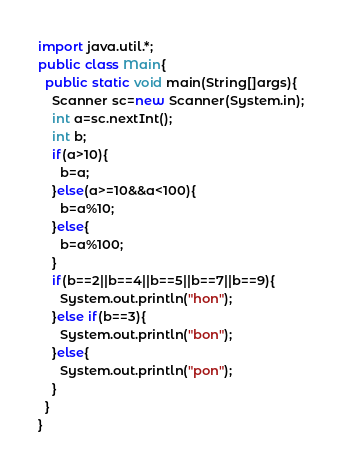Convert code to text. <code><loc_0><loc_0><loc_500><loc_500><_Java_>import java.util.*;
public class Main{
  public static void main(String[]args){
    Scanner sc=new Scanner(System.in);
    int a=sc.nextInt();
    int b;
    if(a>10){
      b=a;
    }else(a>=10&&a<100){
      b=a%10;
    }else{
      b=a%100;
    }
    if(b==2||b==4||b==5||b==7||b==9){
      System.out.println("hon");
    }else if(b==3){
      System.out.println("bon");
    }else{
      System.out.println("pon");
    }
  }
}</code> 